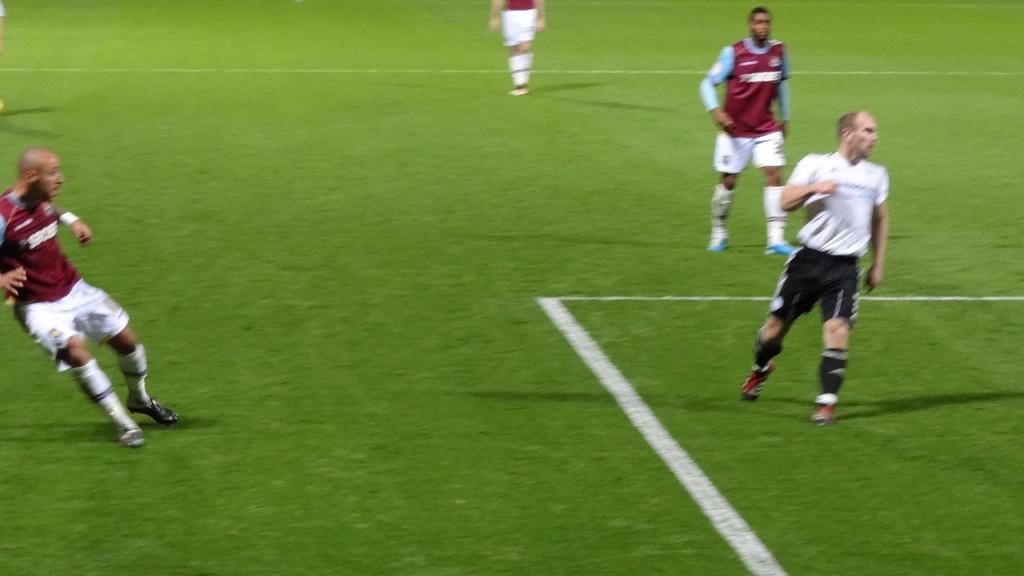How would you summarize this image in a sentence or two? This is the picture of a ground on which there are some people wearing shorts, shoes and there are some white lines on the floor. 